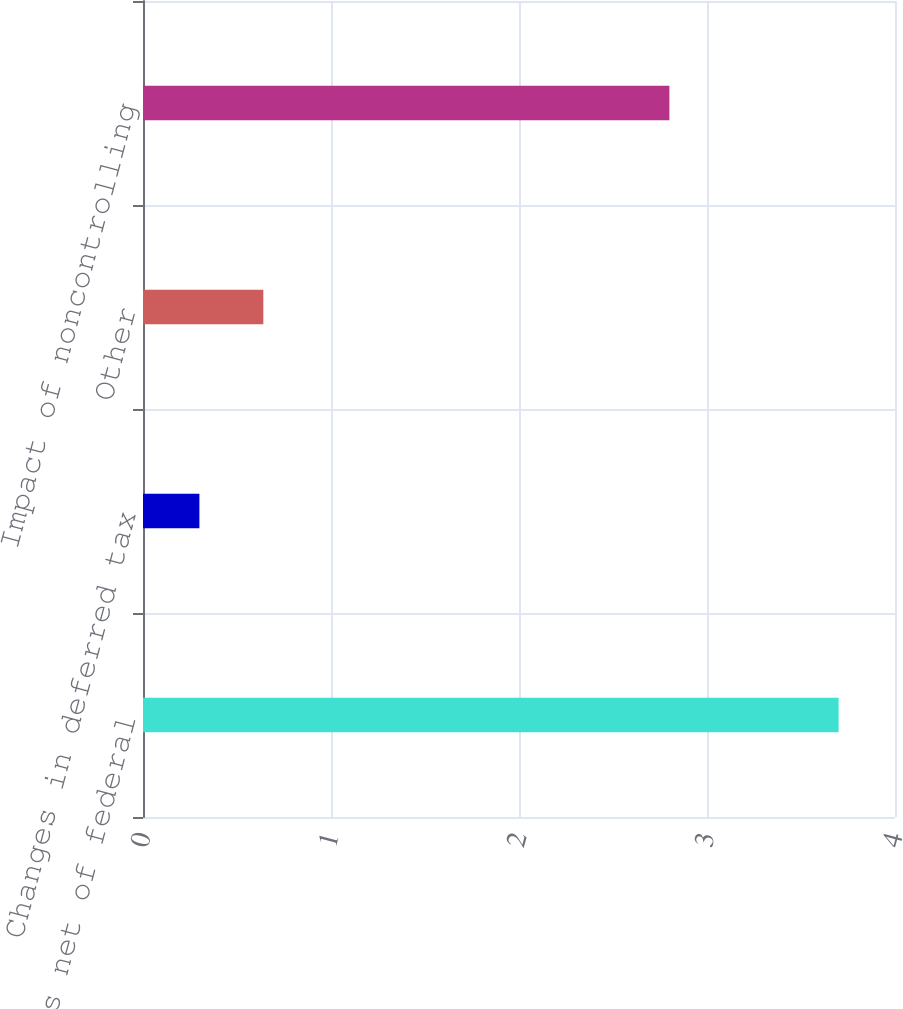<chart> <loc_0><loc_0><loc_500><loc_500><bar_chart><fcel>State taxes net of federal<fcel>Changes in deferred tax<fcel>Other<fcel>Impact of noncontrolling<nl><fcel>3.7<fcel>0.3<fcel>0.64<fcel>2.8<nl></chart> 